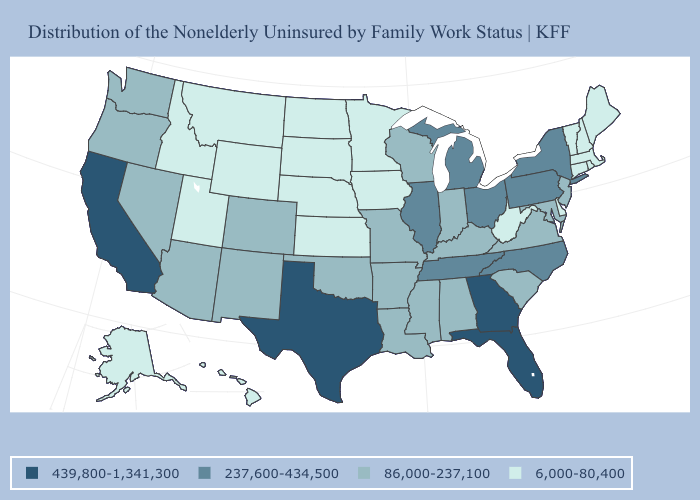Among the states that border South Carolina , which have the lowest value?
Give a very brief answer. North Carolina. What is the lowest value in the South?
Quick response, please. 6,000-80,400. Name the states that have a value in the range 86,000-237,100?
Short answer required. Alabama, Arizona, Arkansas, Colorado, Indiana, Kentucky, Louisiana, Maryland, Mississippi, Missouri, Nevada, New Jersey, New Mexico, Oklahoma, Oregon, South Carolina, Virginia, Washington, Wisconsin. What is the value of Colorado?
Concise answer only. 86,000-237,100. What is the lowest value in states that border South Carolina?
Write a very short answer. 237,600-434,500. Which states hav the highest value in the MidWest?
Answer briefly. Illinois, Michigan, Ohio. Does Montana have the highest value in the West?
Give a very brief answer. No. Is the legend a continuous bar?
Give a very brief answer. No. Does the map have missing data?
Concise answer only. No. Name the states that have a value in the range 237,600-434,500?
Answer briefly. Illinois, Michigan, New York, North Carolina, Ohio, Pennsylvania, Tennessee. Is the legend a continuous bar?
Answer briefly. No. Does the first symbol in the legend represent the smallest category?
Give a very brief answer. No. Which states have the lowest value in the USA?
Quick response, please. Alaska, Connecticut, Delaware, Hawaii, Idaho, Iowa, Kansas, Maine, Massachusetts, Minnesota, Montana, Nebraska, New Hampshire, North Dakota, Rhode Island, South Dakota, Utah, Vermont, West Virginia, Wyoming. Name the states that have a value in the range 439,800-1,341,300?
Quick response, please. California, Florida, Georgia, Texas. Which states have the highest value in the USA?
Keep it brief. California, Florida, Georgia, Texas. 